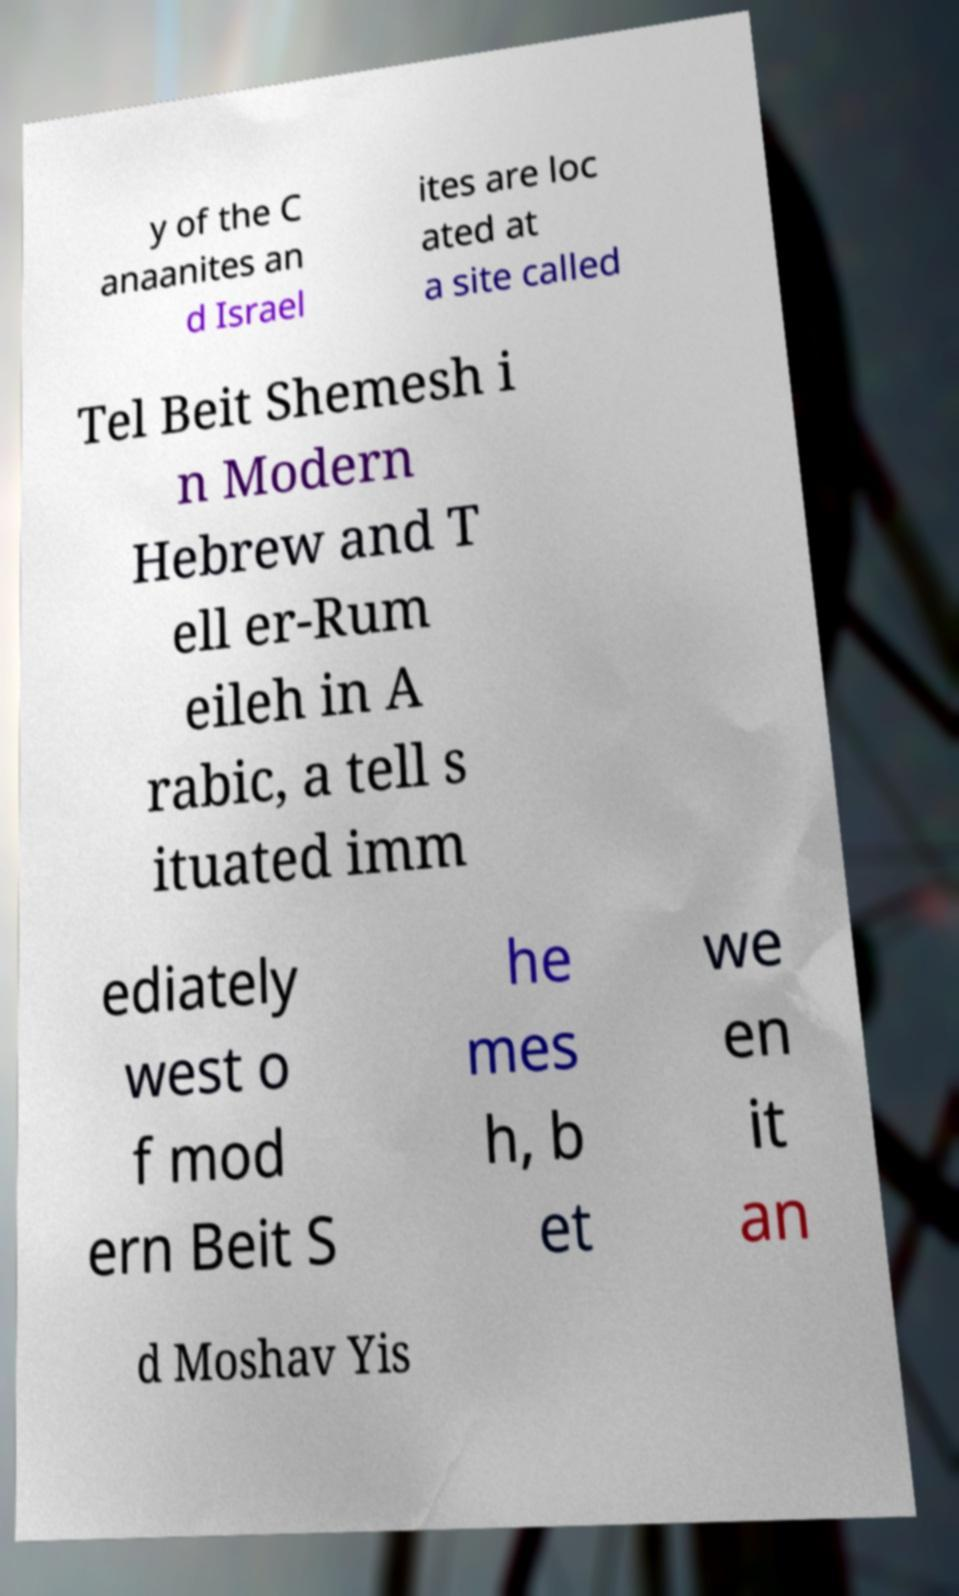Can you read and provide the text displayed in the image?This photo seems to have some interesting text. Can you extract and type it out for me? y of the C anaanites an d Israel ites are loc ated at a site called Tel Beit Shemesh i n Modern Hebrew and T ell er-Rum eileh in A rabic, a tell s ituated imm ediately west o f mod ern Beit S he mes h, b et we en it an d Moshav Yis 